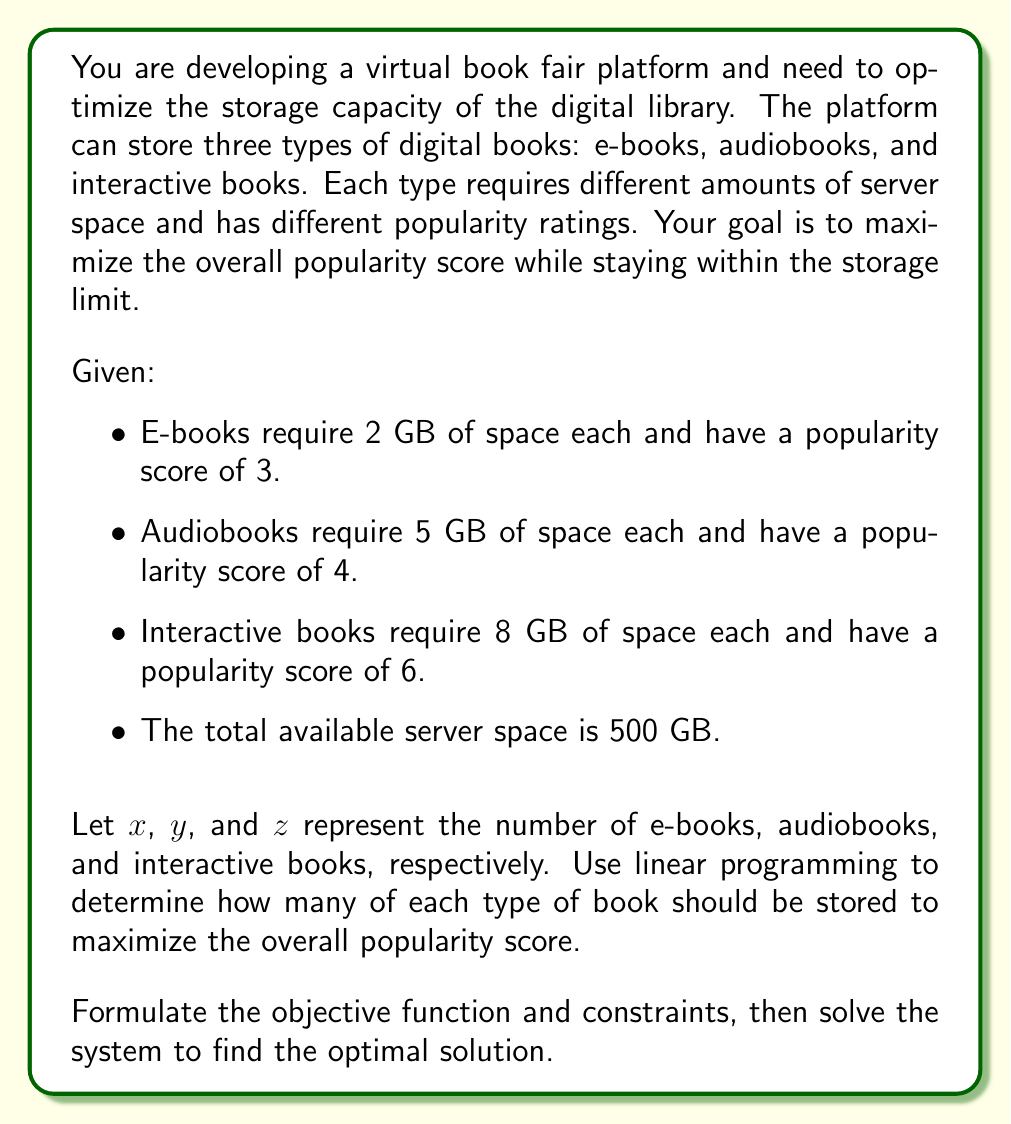Can you answer this question? To solve this linear programming problem, we'll follow these steps:

1. Formulate the objective function
2. Identify the constraints
3. Set up the system of equations
4. Solve the system using the simplex method or graphical method

Step 1: Formulate the objective function

The objective is to maximize the overall popularity score. We can express this as:

$$P = 3x + 4y + 6z$$

Where $P$ is the total popularity score, and $x$, $y$, and $z$ are the numbers of e-books, audiobooks, and interactive books, respectively.

Step 2: Identify the constraints

We have one main constraint: the total storage space. We can express this as:

$$2x + 5y + 8z \leq 500$$

Additionally, we need non-negativity constraints:

$$x \geq 0, y \geq 0, z \geq 0$$

Step 3: Set up the system of equations

Our linear programming problem can be expressed as:

Maximize: $P = 3x + 4y + 6z$
Subject to:
$$2x + 5y + 8z \leq 500$$
$$x \geq 0, y \geq 0, z \geq 0$$

Step 4: Solve the system

To solve this system, we can use the simplex method or a graphical method. For simplicity, we'll use a graphical approach by considering the extreme points of the feasible region.

The extreme points are:
(250, 0, 0), (0, 100, 0), (0, 0, 62.5), (125, 50, 0), (0, 60, 25), (100, 0, 37.5)

Evaluating the objective function at these points:

1. P(250, 0, 0) = 750
2. P(0, 100, 0) = 400
3. P(0, 0, 62.5) = 375
4. P(125, 50, 0) = 575
5. P(0, 60, 25) = 390
6. P(100, 0, 37.5) = 525

The maximum value occurs at the point (250, 0, 0), which corresponds to storing 250 e-books, 0 audiobooks, and 0 interactive books.
Answer: The optimal solution is to store 250 e-books, 0 audiobooks, and 0 interactive books, resulting in a maximum popularity score of 750. 